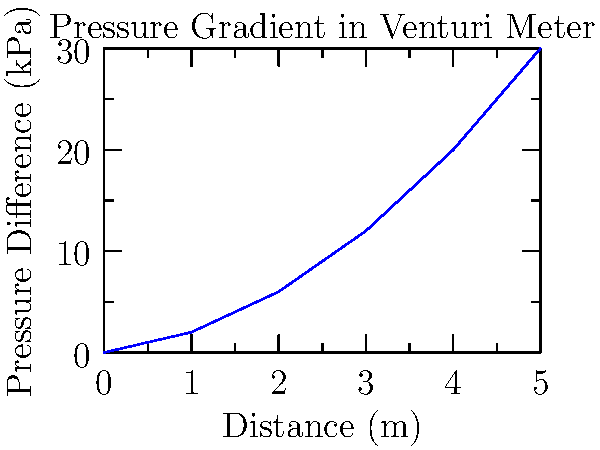A venturi meter is used to measure the flow rate of a fluid. The graph shows the pressure difference along the length of the meter. Given that the density of the fluid is 1000 kg/m³ and the area ratio of the throat to the inlet is 0.5, calculate the flow rate through the meter in m³/s. To calculate the flow rate through a venturi meter using the pressure gradient graph, we'll follow these steps:

1. Determine the maximum pressure difference from the graph:
   The maximum pressure difference occurs at the end of the graph, which is 30 kPa.

2. Convert the pressure difference to Pascals:
   30 kPa = 30,000 Pa

3. Use the venturi meter equation to calculate the flow rate:

   $$Q = C_d A_2 \sqrt{\frac{2\Delta P}{\rho(1-\beta^4)}}$$

   Where:
   $Q$ = Flow rate (m³/s)
   $C_d$ = Discharge coefficient (typically 0.98 for venturi meters)
   $A_2$ = Area of the throat
   $\Delta P$ = Pressure difference (Pa)
   $\rho$ = Density of the fluid (kg/m³)
   $\beta$ = Area ratio (A₂/A₁)

4. We know:
   $C_d$ = 0.98 (assumed)
   $\Delta P$ = 30,000 Pa
   $\rho$ = 1000 kg/m³
   $\beta$ = 0.5

5. Calculate $A_2$ using the area ratio:
   $A_2 = \beta^2 A_1$, but we don't know $A_1$. We can leave it as $A_1$ in our equation.

6. Substitute the values into the equation:

   $$Q = 0.98 (0.5^2 A_1) \sqrt{\frac{2(30,000)}{1000(1-0.5^4)}}$$

7. Simplify:

   $$Q = 0.245 A_1 \sqrt{\frac{60}{0.9375}} = 0.245 A_1 \sqrt{64} = 0.245 A_1 (8) = 1.96 A_1$$

Therefore, the flow rate is 1.96 times the inlet area $A_1$ in m³/s.
Answer: $Q = 1.96 A_1$ m³/s 